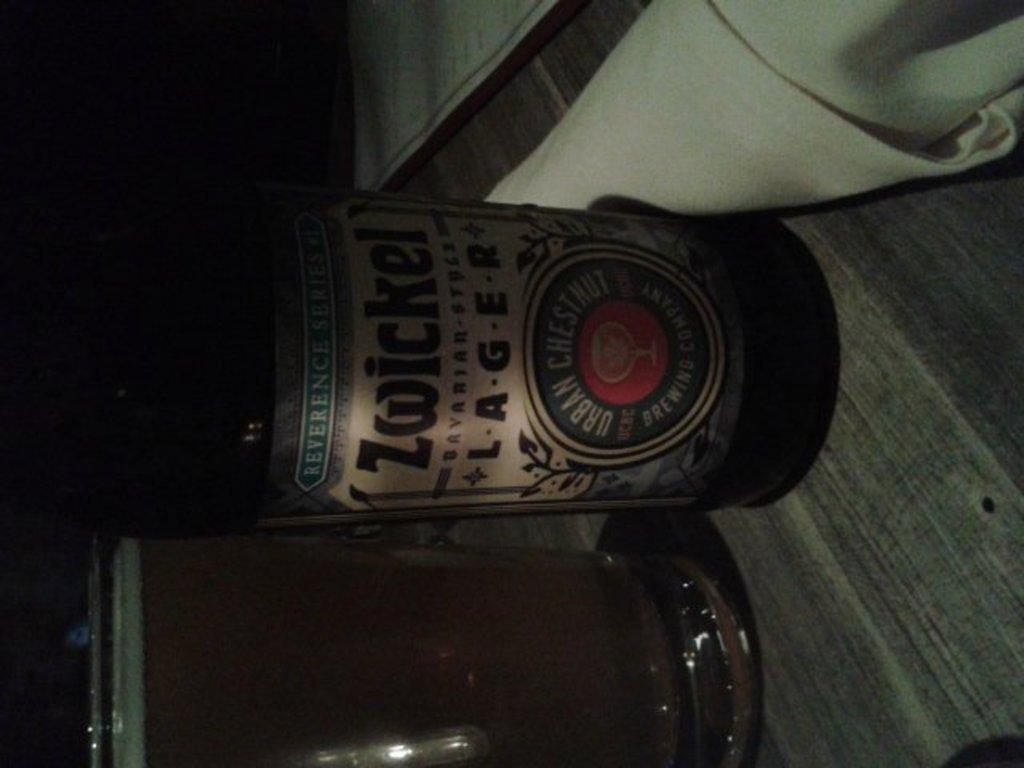<image>
Relay a brief, clear account of the picture shown. A bottle of Zwickel Lager sits on a dark table 